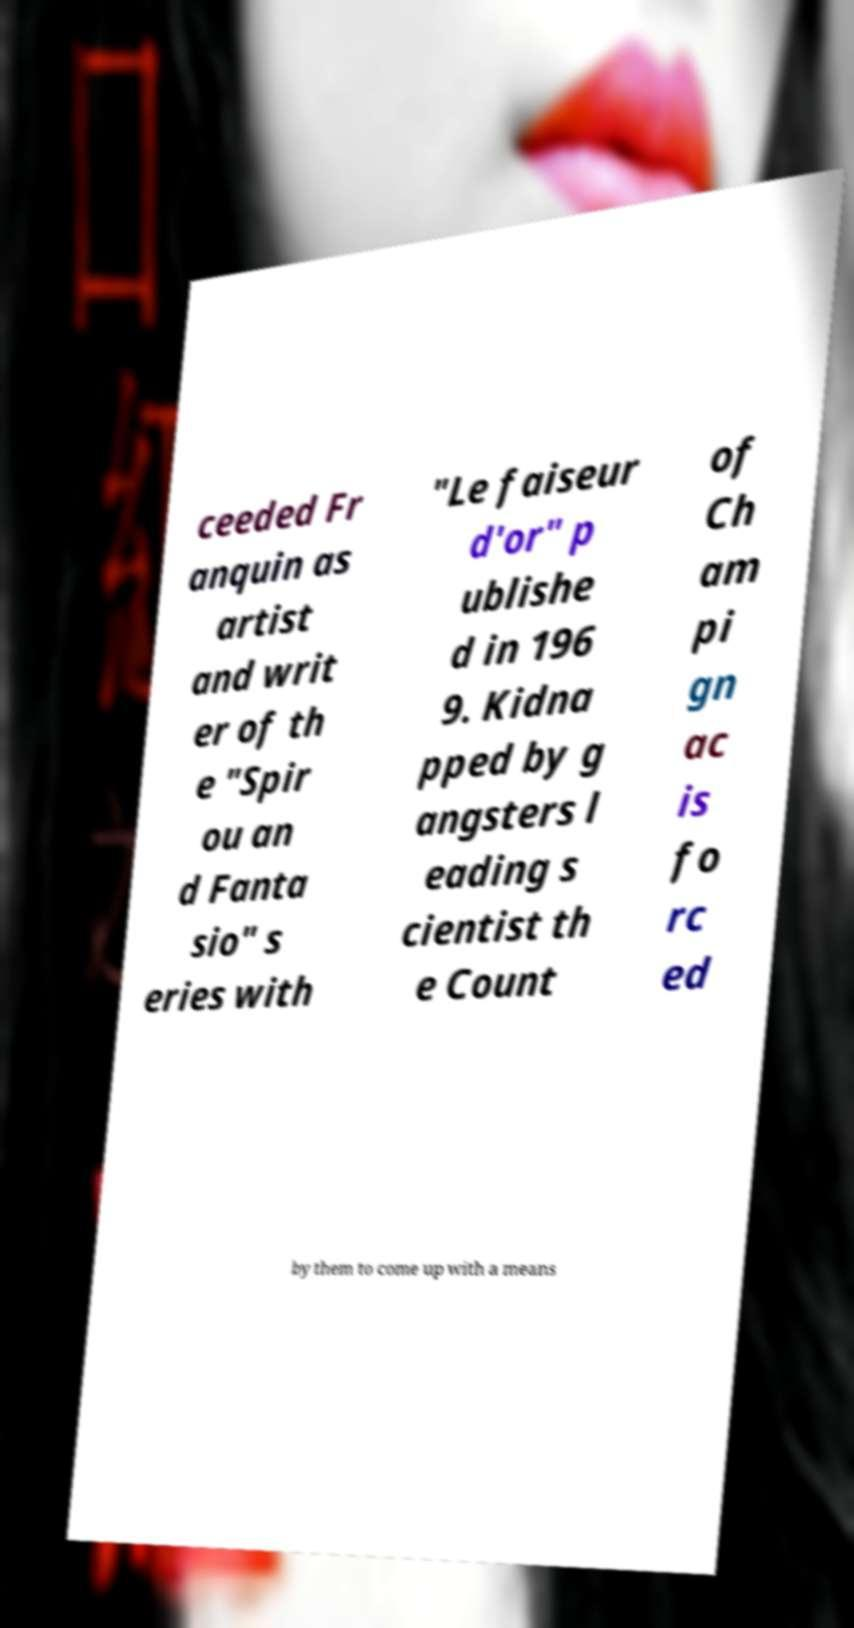Please identify and transcribe the text found in this image. ceeded Fr anquin as artist and writ er of th e "Spir ou an d Fanta sio" s eries with "Le faiseur d'or" p ublishe d in 196 9. Kidna pped by g angsters l eading s cientist th e Count of Ch am pi gn ac is fo rc ed by them to come up with a means 